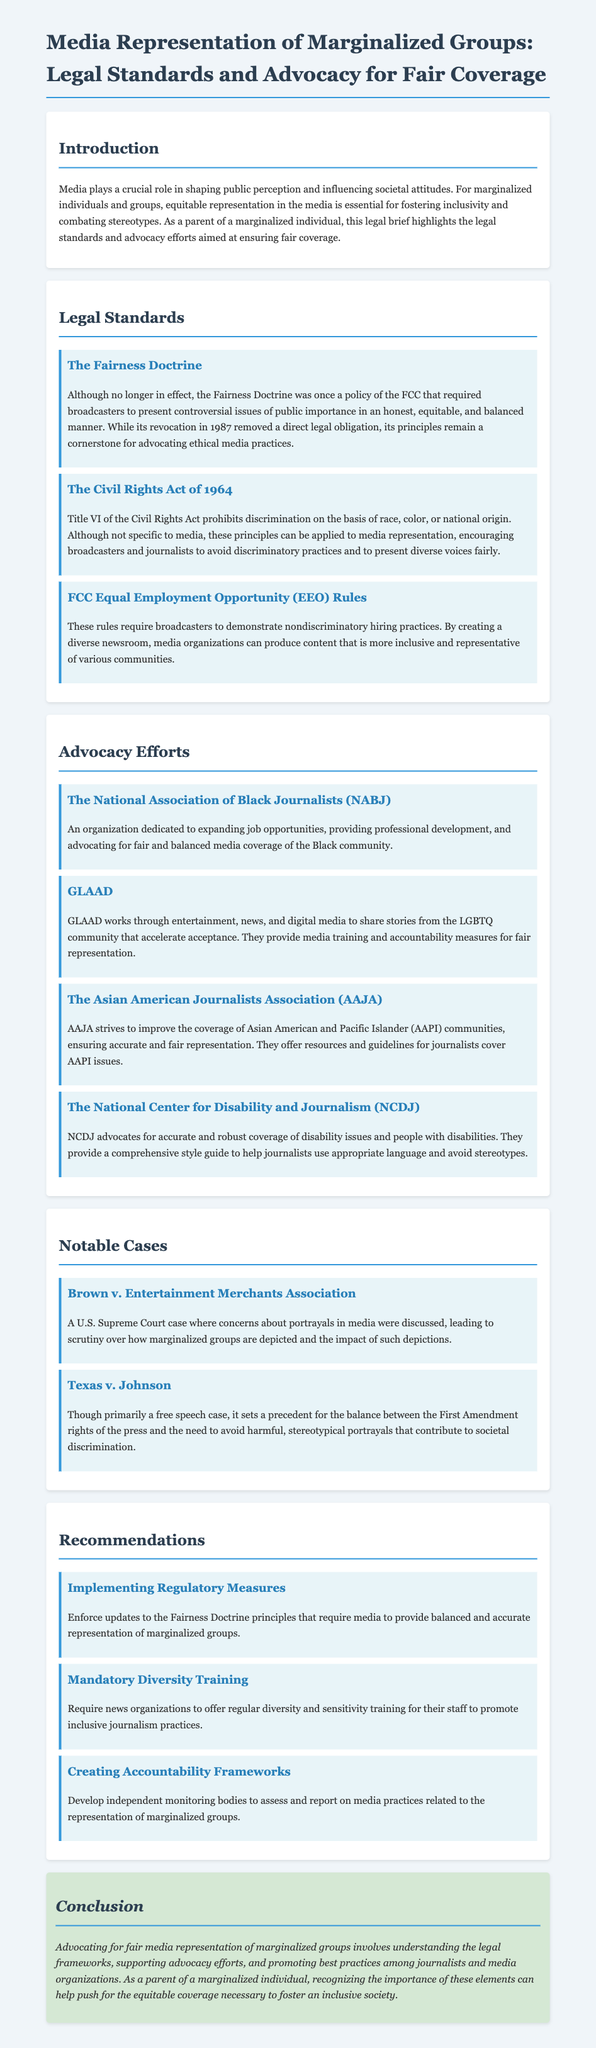What was the Fairness Doctrine? The Fairness Doctrine was a policy of the FCC that required broadcasters to present controversial issues of public importance in an honest, equitable, and balanced manner.
Answer: A policy of the FCC What does Title VI of the Civil Rights Act prohibit? Title VI of the Civil Rights Act prohibits discrimination on the basis of race, color, or national origin.
Answer: Discrimination on the basis of race, color, or national origin What organization advocates for the Black community in media? The National Association of Black Journalists is dedicated to advocating for fair and balanced media coverage of the Black community.
Answer: National Association of Black Journalists Which case discusses media portrayals and marginalized groups? Brown v. Entertainment Merchants Association discusses concerns about portrayals in media.
Answer: Brown v. Entertainment Merchants Association What is one recommendation for promoting inclusive journalism practices? One recommendation is to require news organizations to offer regular diversity and sensitivity training for their staff.
Answer: Mandatory Diversity Training 